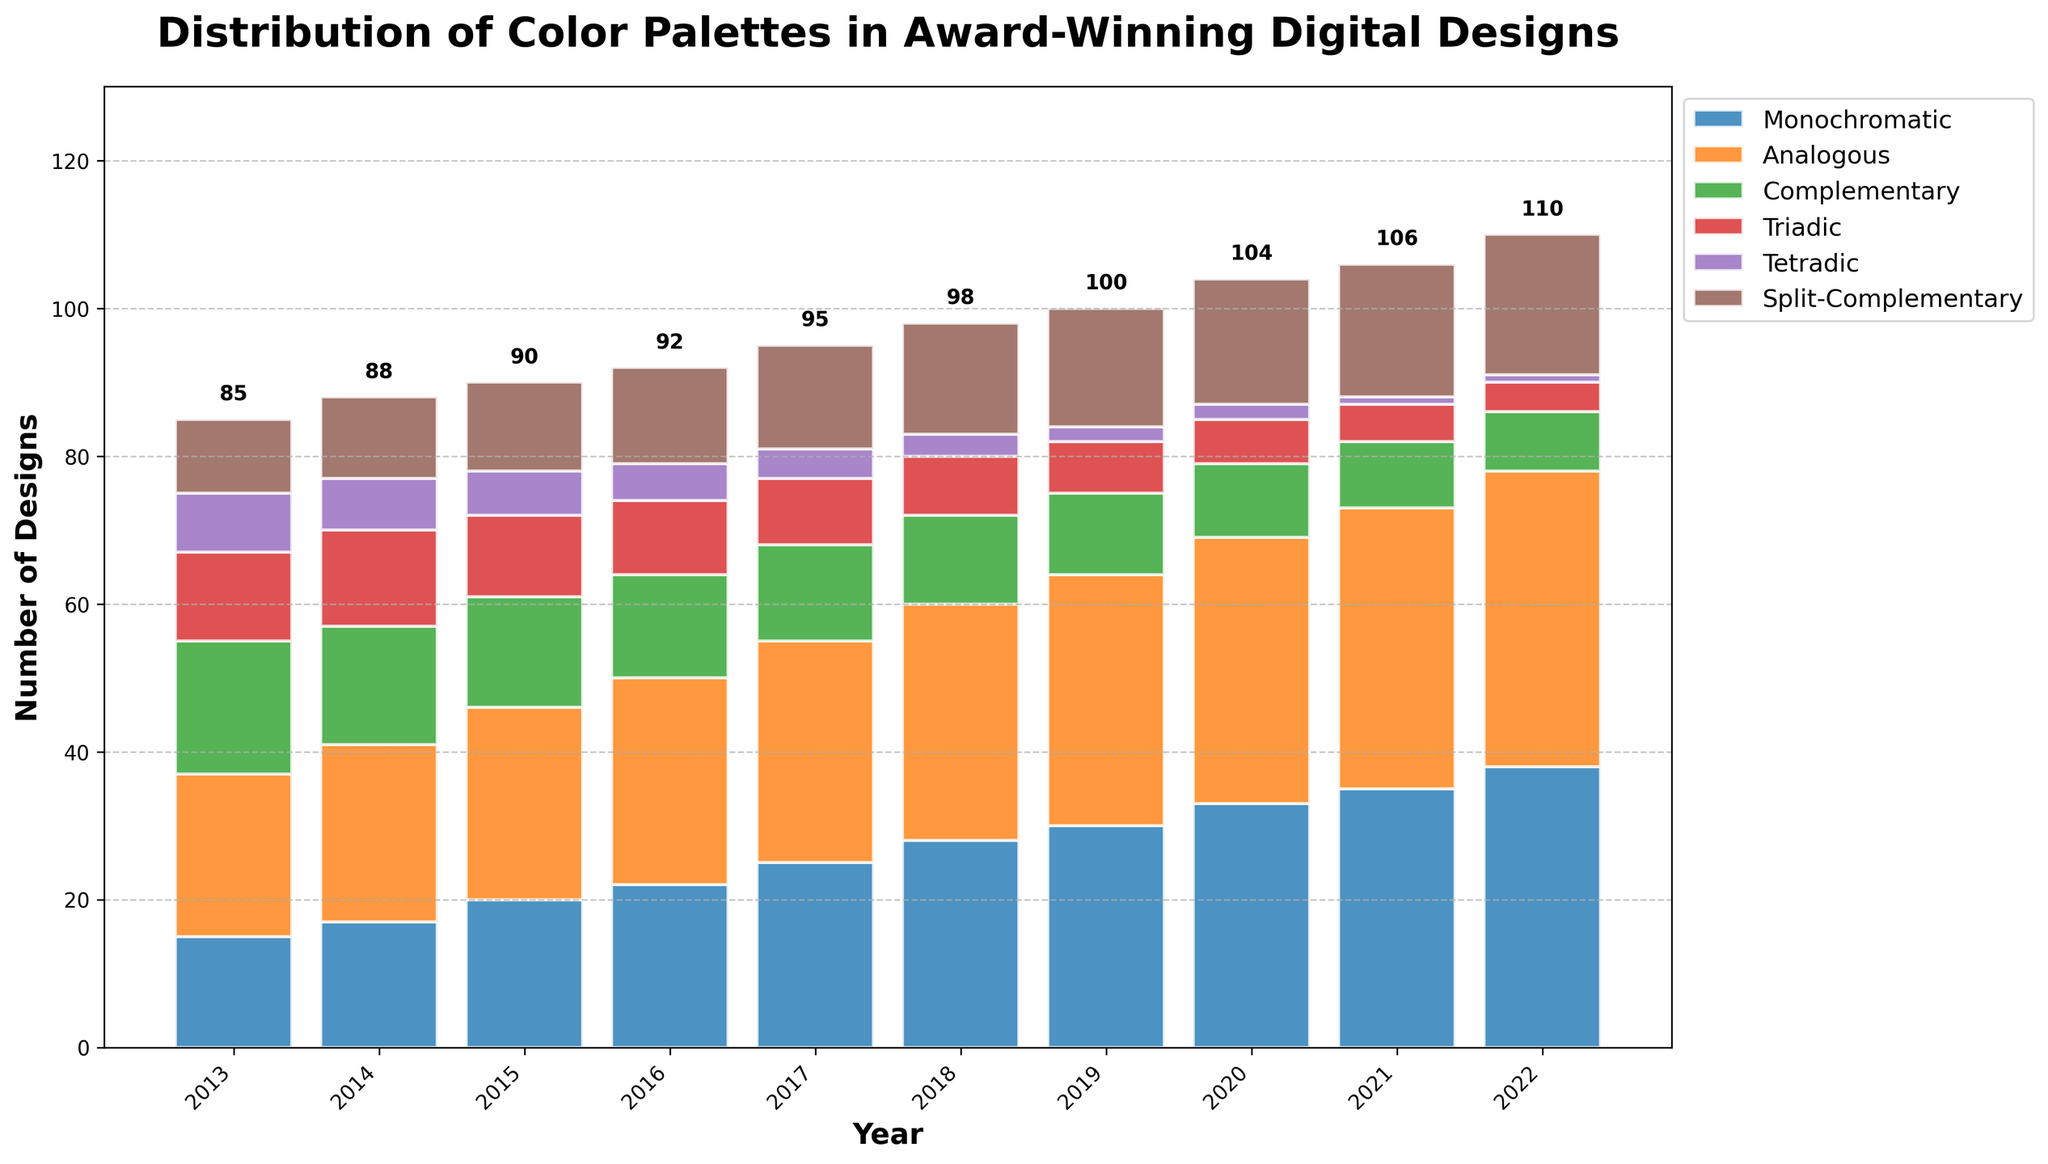What is the total number of award-winning designs in 2020? First, find the individual values for each color palette in the year 2020: Monochromatic (33), Analogous (36), Complementary (10), Triadic (6), Tetradic (2), and Split-Complementary (17). Summing these values gives 33 + 36 + 10 + 6 + 2 + 17 = 104.
Answer: 104 Which color palette was used the least in 2022? Look at the values for all color palettes in 2022 and identify the smallest value: Monochromatic (38), Analogous (40), Complementary (8), Triadic (4), Tetradic (1), and Split-Complementary (19). The smallest value is for the Tetradic palette.
Answer: Tetradic How did the use of Monochromatic palettes change from 2013 to 2022? In 2013, the number of Monochromatic designs was 15. In 2022, it was 38. Calculate the difference between these two values: 38 - 15 = 23.
Answer: Increased by 23 Across the years, which color palette shows the most consistent growth in usage? Analyze the trendline for each color palette over the years from 2013 to 2022. The Analogous palette consistently increases each year, from 22 in 2013 to 40 in 2022, showing the most consistent growth.
Answer: Analogous What is the combined total of designs using Triadic and Split-Complementary palettes in 2019? Find the number of Triadic (7) and Split-Complementary (16) designs in 2019. Sum these values: 7 + 16 = 23.
Answer: 23 Which year had the highest number of designs using Complementary palettes, and how many designs used this palette that year? Looking at the values for Complementary palettes over the years, the peak is in 2013 with 18 designs.
Answer: 2013, 18 How many times did the use of Tetradic palettes equal the use of Split-Complementary palettes over the decade? Compare the values of Tetradic and Split-Complementary palettes for each year to see if any are equal. In 2019 and 2020, the number of Tetradic designs equals 2, the same as Split-Complementary designs. This occurs twice.
Answer: 2 times Compare the use of Monochromatic and Analogous palettes in 2014. Which was higher, and by how much? In 2014, the Monochromatic designs number was 17, and Analogous designs were 24. Calculate the difference: 24 - 17 = 7. Analogous is higher.
Answer: Analogous, by 7 What is the average number of designs using Analogous palettes from 2013 to 2017? Add the number of Analogous designs from 2013 to 2017: 22 + 24 + 26 + 28 + 30 = 130. Divide this total by 5 (the number of years): 130 / 5 = 26.
Answer: 26 